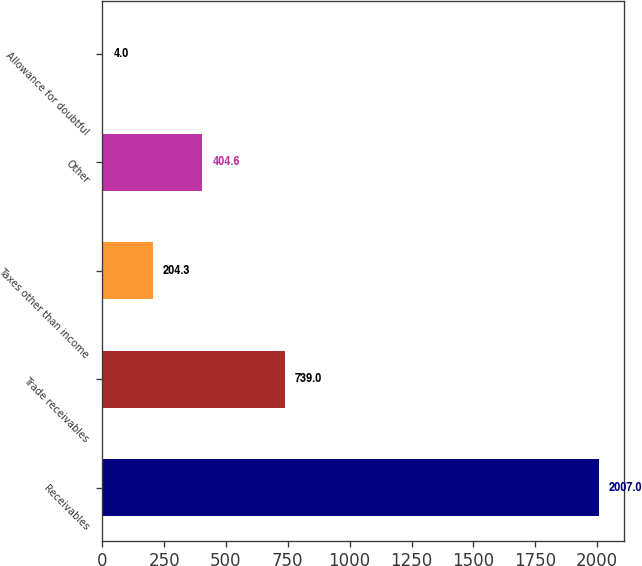<chart> <loc_0><loc_0><loc_500><loc_500><bar_chart><fcel>Receivables<fcel>Trade receivables<fcel>Taxes other than income<fcel>Other<fcel>Allowance for doubtful<nl><fcel>2007<fcel>739<fcel>204.3<fcel>404.6<fcel>4<nl></chart> 